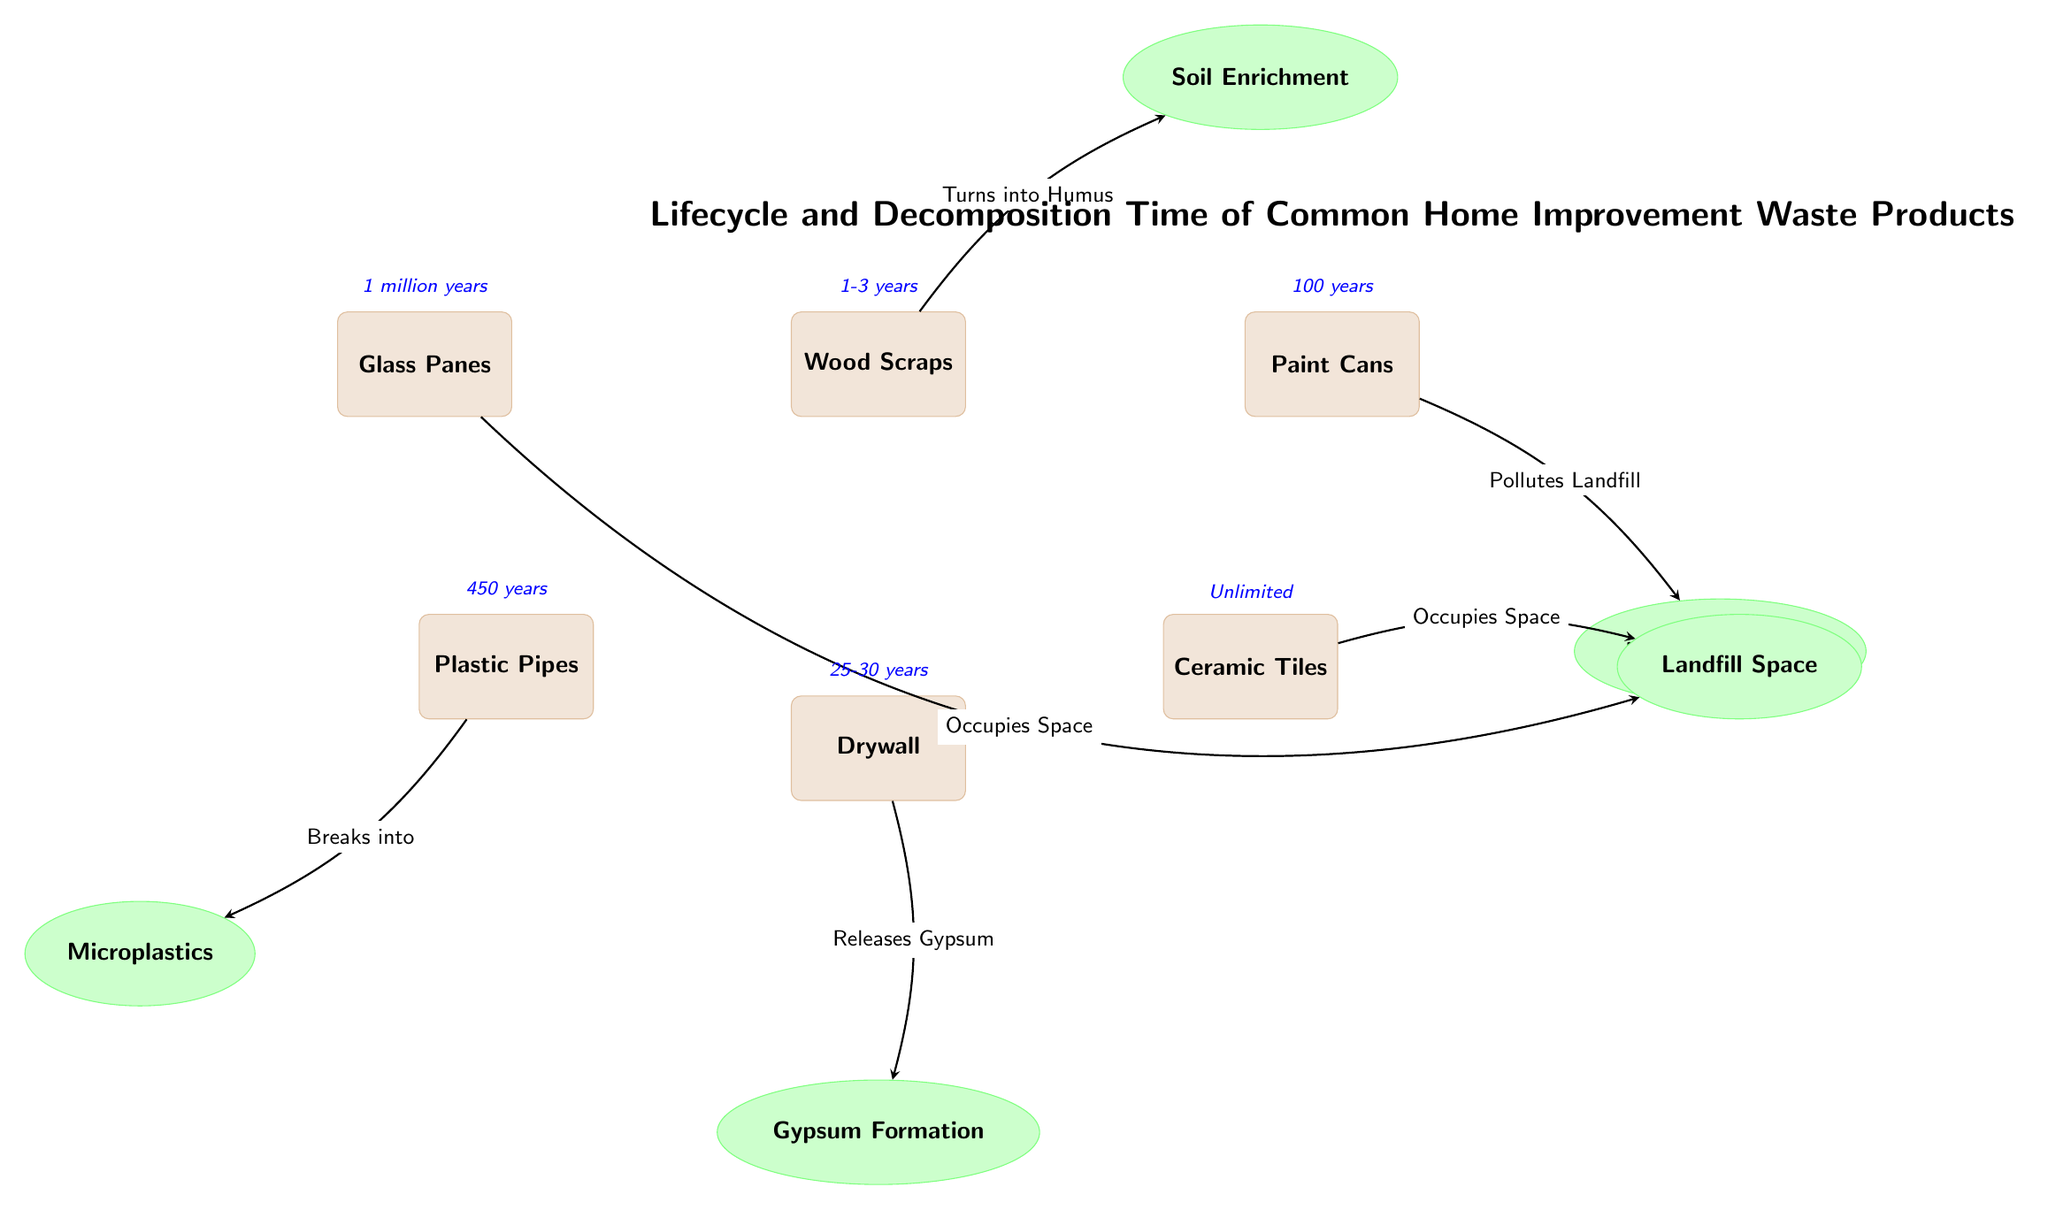What is the decomposition time for wood scraps? The diagram indicates that the decomposition time for wood scraps is listed directly above this waste node, which shows "1-3 years."
Answer: 1-3 years Which waste product takes the longest to decompose? By looking at the decomposition times provided for each waste product, "Glass Panes" has the longest time of "1 million years," which is evident from its associated time label in the diagram.
Answer: 1 million years What effect does drywall have according to the diagram? The diagram connects drywall to the "Gypsum Formation" effect, which is indicated with an arrow pointing towards the gypsy node. This clearly delineates drywall's impact based on the diagram.
Answer: Gypsum Formation How many types of waste products are shown in the diagram? Counting the waste nodes in the diagram, there are a total of six labeled waste products: Wood Scraps, Paint Cans, Ceramic Tiles, Plastic Pipes, Glass Panes, and Drywall. This count highlights the variety of waste represented.
Answer: 6 Which waste product contributes to microplastics? The diagram shows that "Plastic Pipes" breaks into Microplastics, as indicated by the arrow connecting them, making it clear that plastic waste contributes to this environmental concern.
Answer: Plastic Pipes What is the relationship between paint cans and landfill pollution? The diagram depicts an arrow from "Paint Cans" leading to "Landfill Pollution," illustrating that paint cans have a direct effect on pollution when disposed of in landfills.
Answer: Pollutes Landfill What happens to ceramic tiles over time according to the diagram? The diagram states that ceramic tiles "Occupy Space" indefinitely, which is reflected in the label and indicates that they do not decompose meaningfully over time.
Answer: Unlimited Which two waste products contribute to occupying landfill space? The diagram highlights that both "Ceramic Tiles" and "Glass Panes" contribute to landfill space occupation, each having a direct effect as indicated by arrows pointing to the "Landfill Space" node.
Answer: Ceramic Tiles and Glass Panes What transition occurs for wood scraps in the waste lifecycle? The transition for wood scraps is indicated by the arrow leading from "Wood Scraps" to "Soil Enrichment," showing that they transform into humus which enriches the soil as they decompose.
Answer: Turns into Humus 